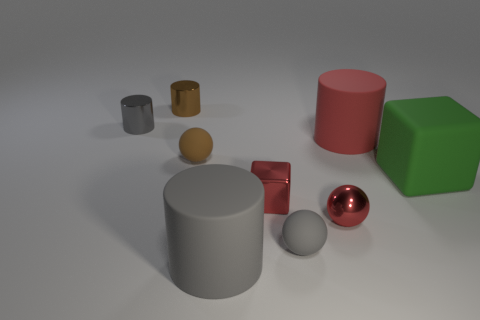What can you tell me about the texture of the green cube? The green cube has a matte finish with no reflections or highlights, suggesting it has a rough or diffused texture. 